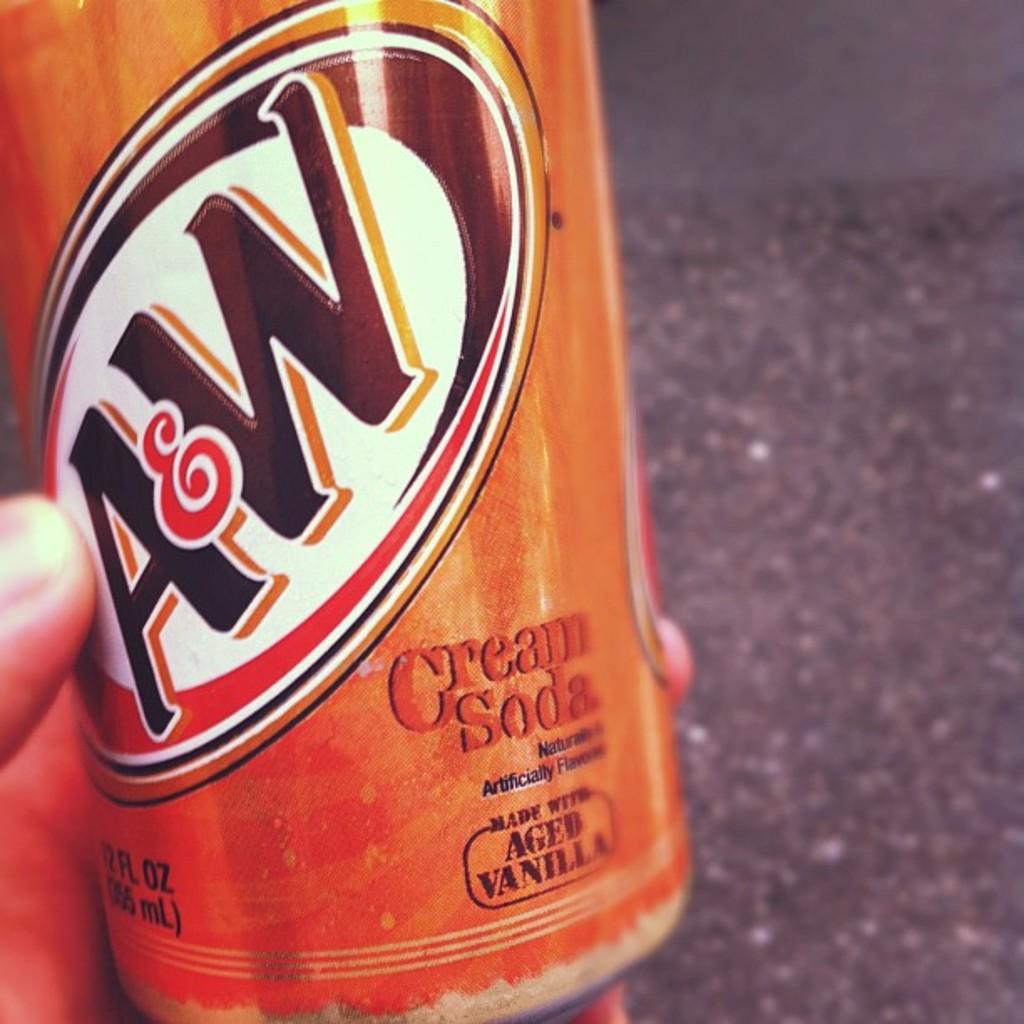What type of soda is this?
Provide a succinct answer. Cream soda. What brand of beverage is this?
Give a very brief answer. A&w. 